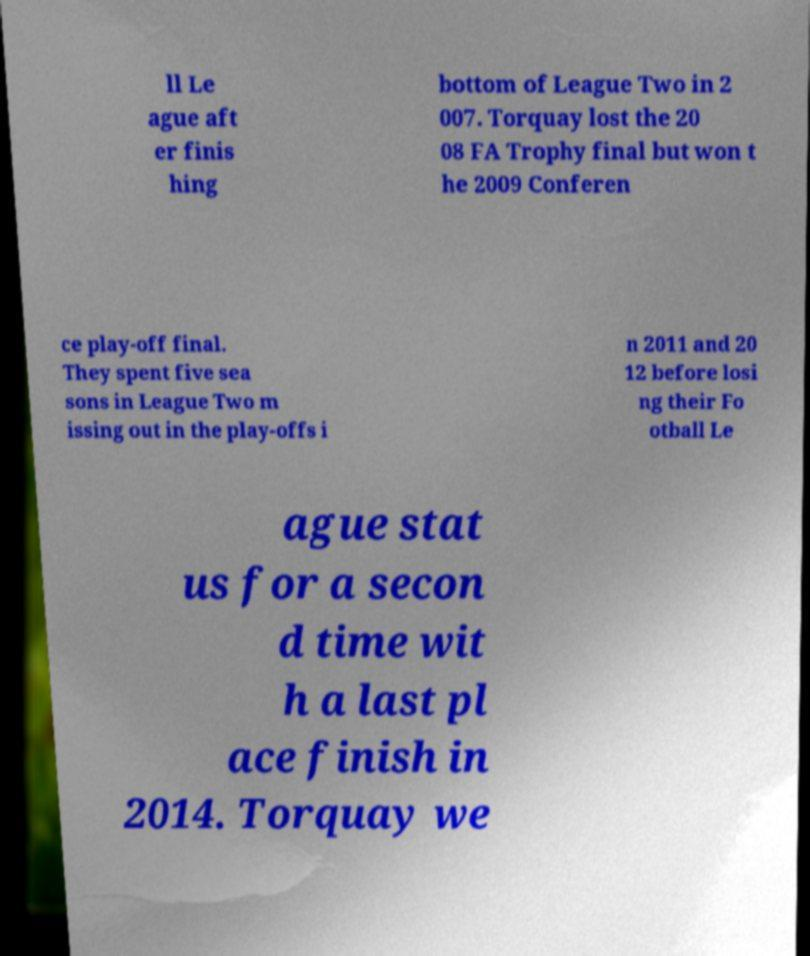Could you extract and type out the text from this image? ll Le ague aft er finis hing bottom of League Two in 2 007. Torquay lost the 20 08 FA Trophy final but won t he 2009 Conferen ce play-off final. They spent five sea sons in League Two m issing out in the play-offs i n 2011 and 20 12 before losi ng their Fo otball Le ague stat us for a secon d time wit h a last pl ace finish in 2014. Torquay we 